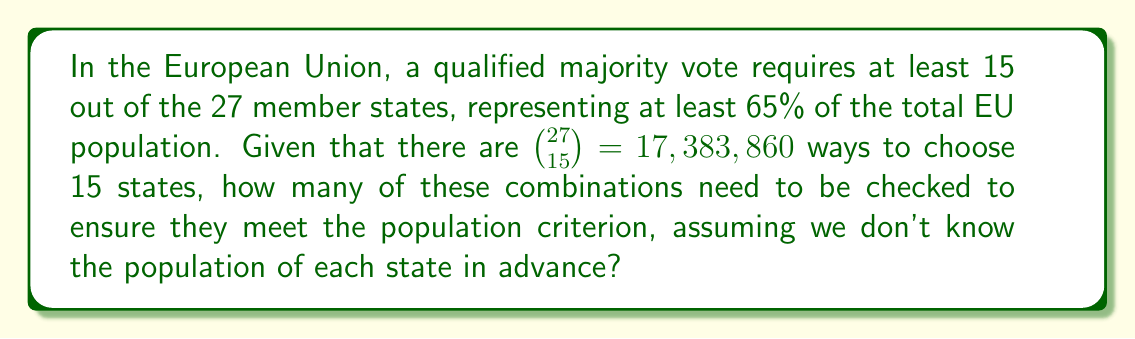Show me your answer to this math problem. To solve this problem, we need to consider the following steps:

1) First, we need to understand what the question is asking. We're looking at all possible combinations of 15 out of 27 EU member states.

2) The total number of these combinations is given by the binomial coefficient:

   $$\binom{27}{15} = \frac{27!}{15!(27-15)!} = \frac{27!}{15!12!} = 17,383,860$$

3) Now, the question is asking how many of these combinations we need to check for the population criterion. 

4) Since we don't know the population of each state in advance, we can't eliminate any combinations without checking.

5) Therefore, we would need to check every single combination to ensure it meets the 65% population criterion.

6) This means we need to check all 17,383,860 combinations.

Thus, the number of combinations that need to be checked is equal to the total number of combinations of 15 out of 27 member states.
Answer: 17,383,860 